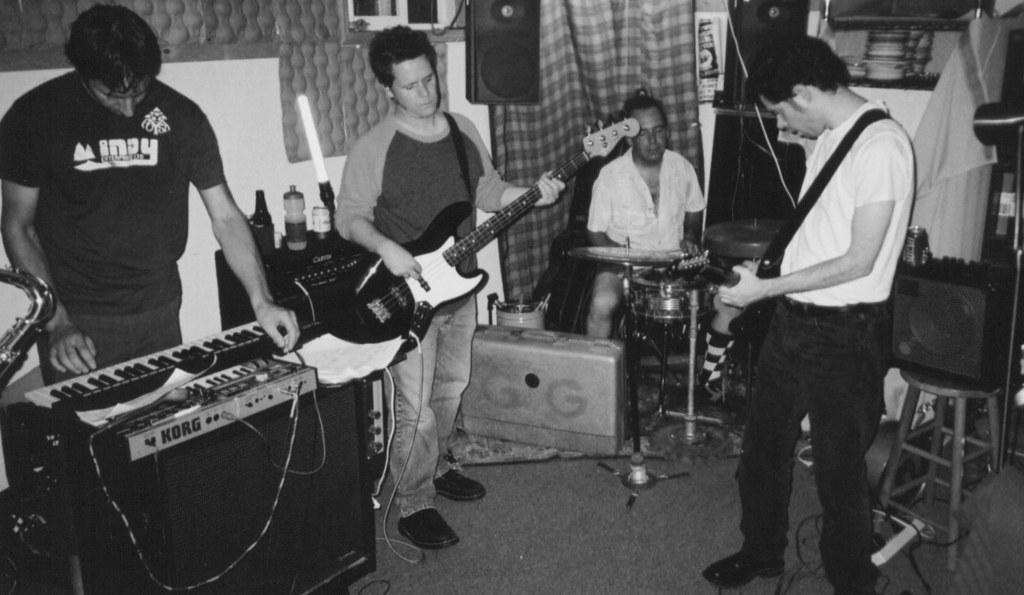Please provide a concise description of this image. In this image I can see four people where three of them standing and one is sitting next to a drum set. Here I can see two of them are holding guitars. I can also see a musical keyboard, a speaker and few bottles. 